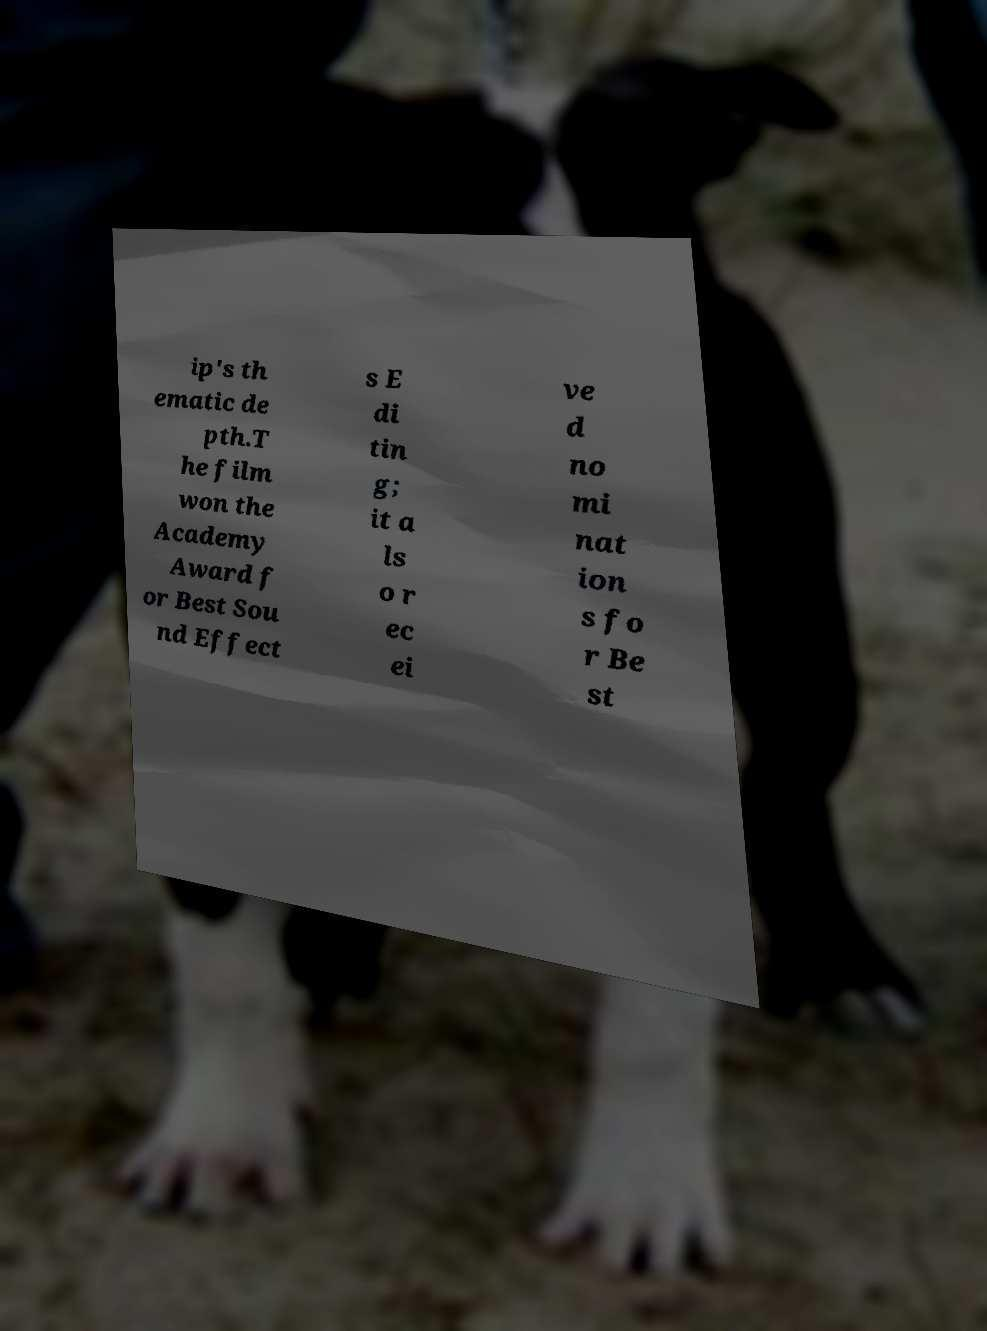I need the written content from this picture converted into text. Can you do that? ip's th ematic de pth.T he film won the Academy Award f or Best Sou nd Effect s E di tin g; it a ls o r ec ei ve d no mi nat ion s fo r Be st 